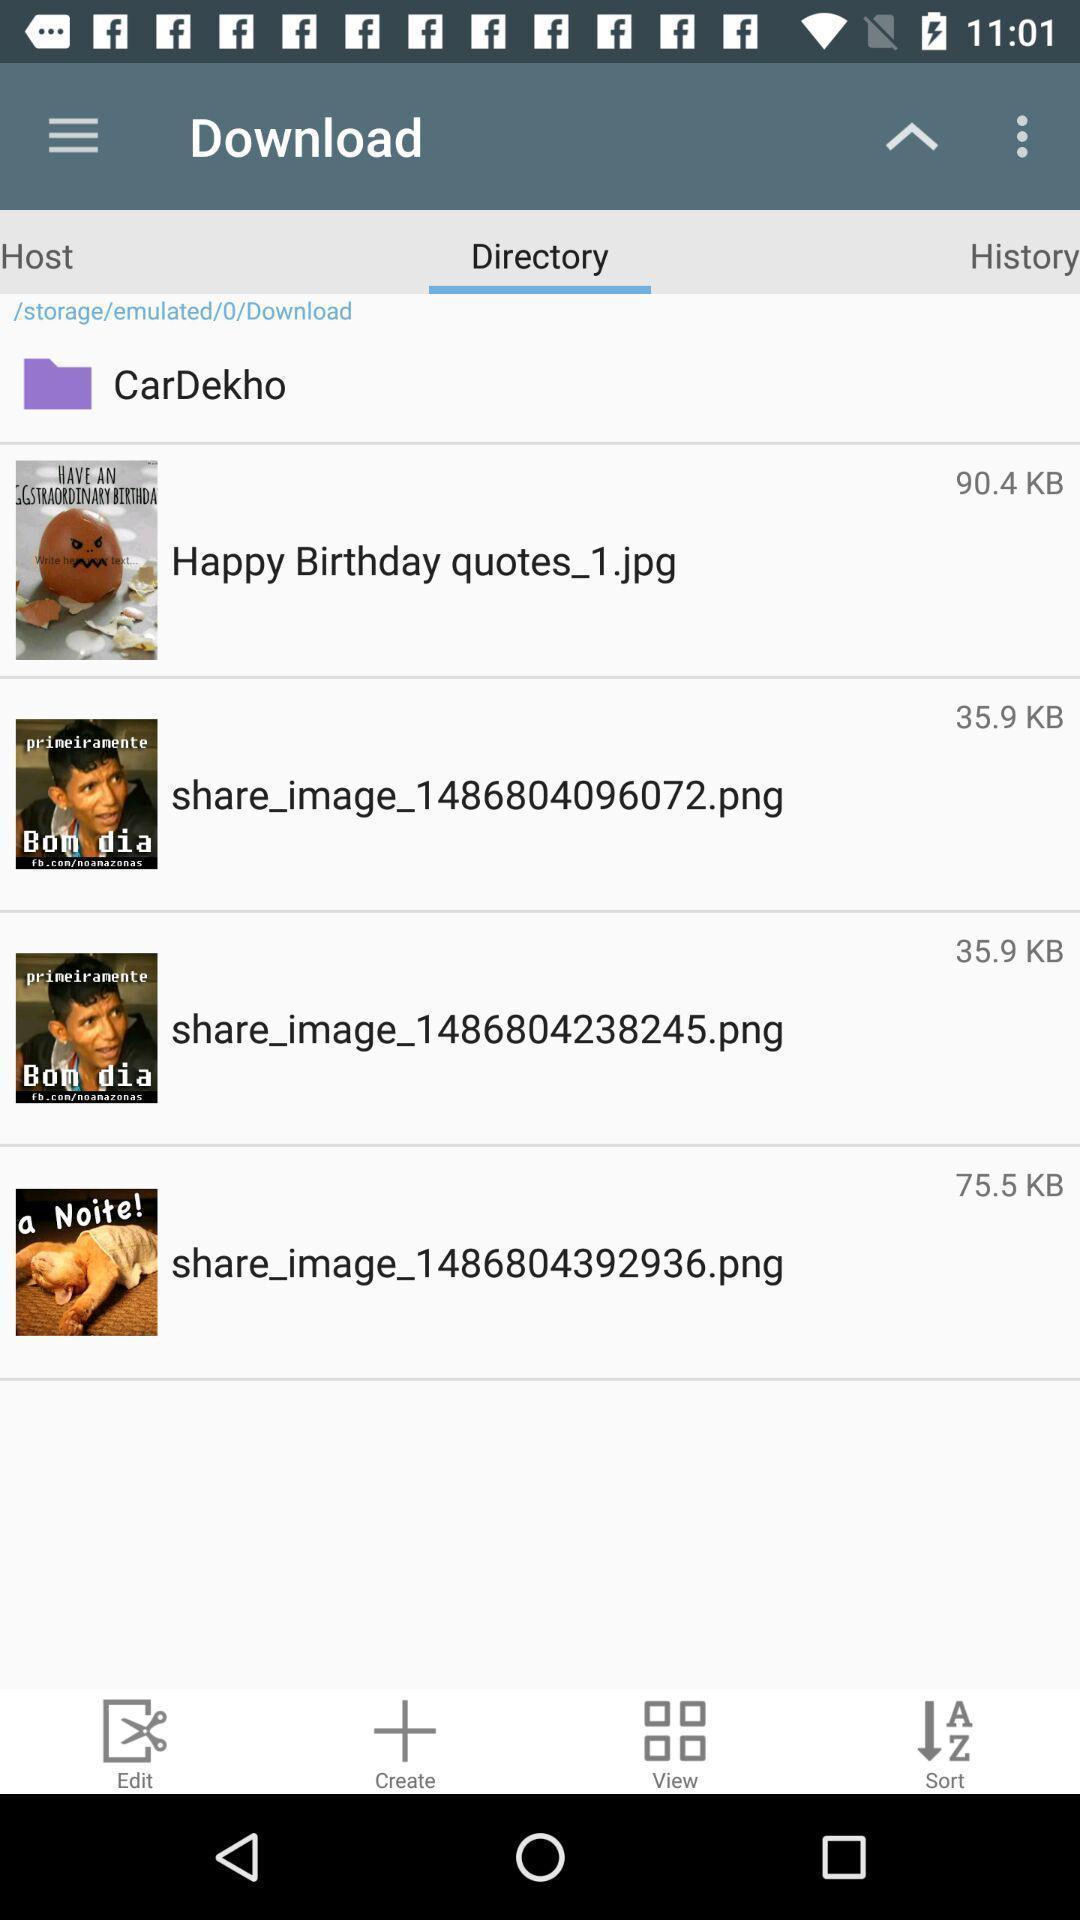What can you discern from this picture? Screen shows download details. 